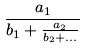Convert formula to latex. <formula><loc_0><loc_0><loc_500><loc_500>\frac { a _ { 1 } } { b _ { 1 } + \frac { a _ { 2 } } { b _ { 2 } + \dots } }</formula> 